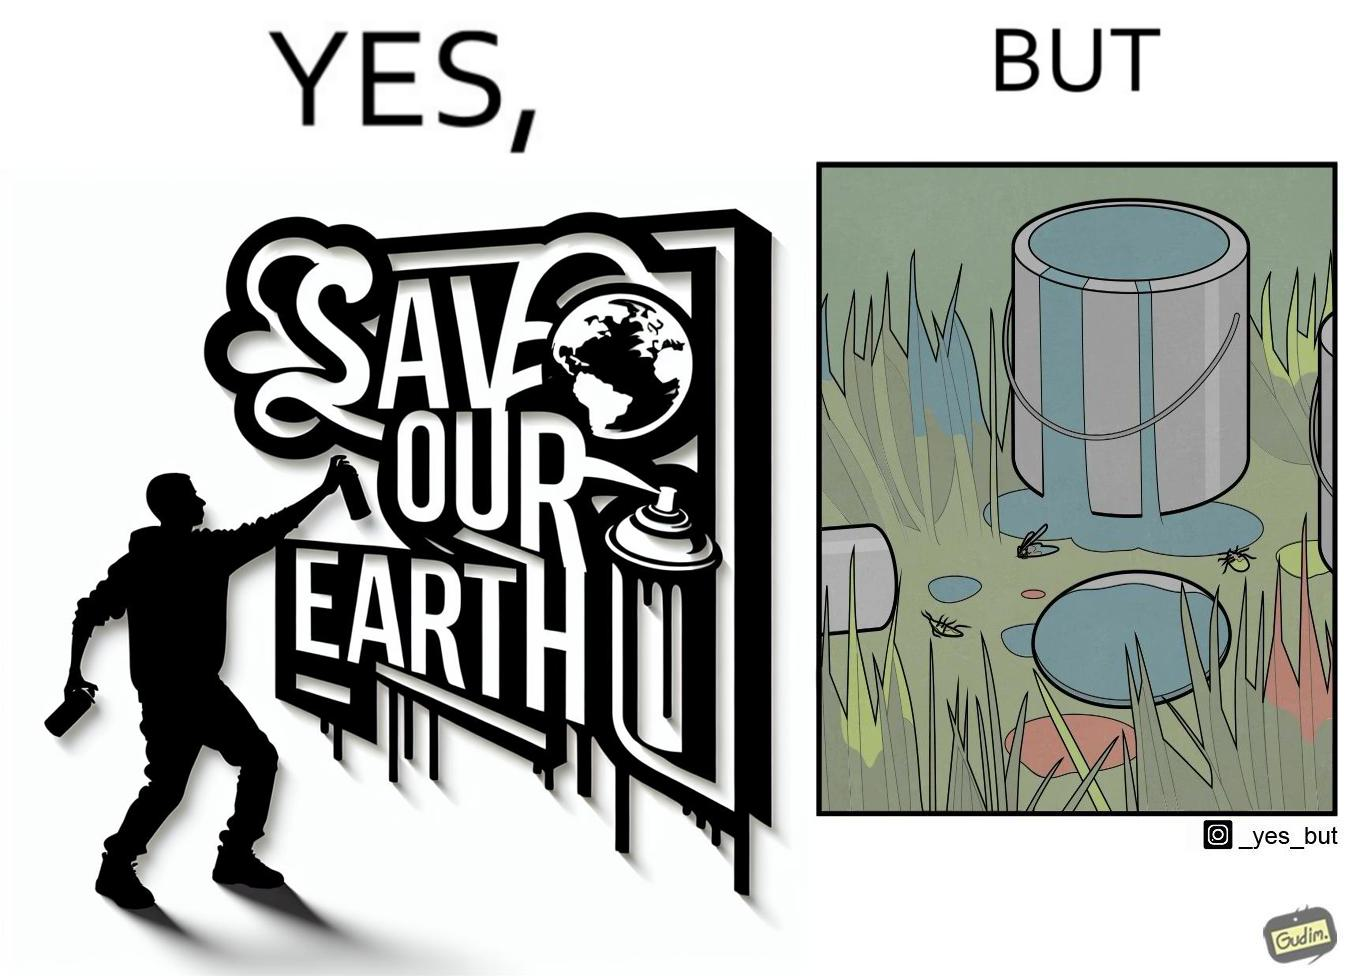Describe the content of this image. The image is ironical, as the cans of paint used to make graffiti on the theme "Save the Earth" seems to be destroying the Earth when it overflows on the grass, as it is harmful for the flora and fauna, as can be seen from the dying insects. 